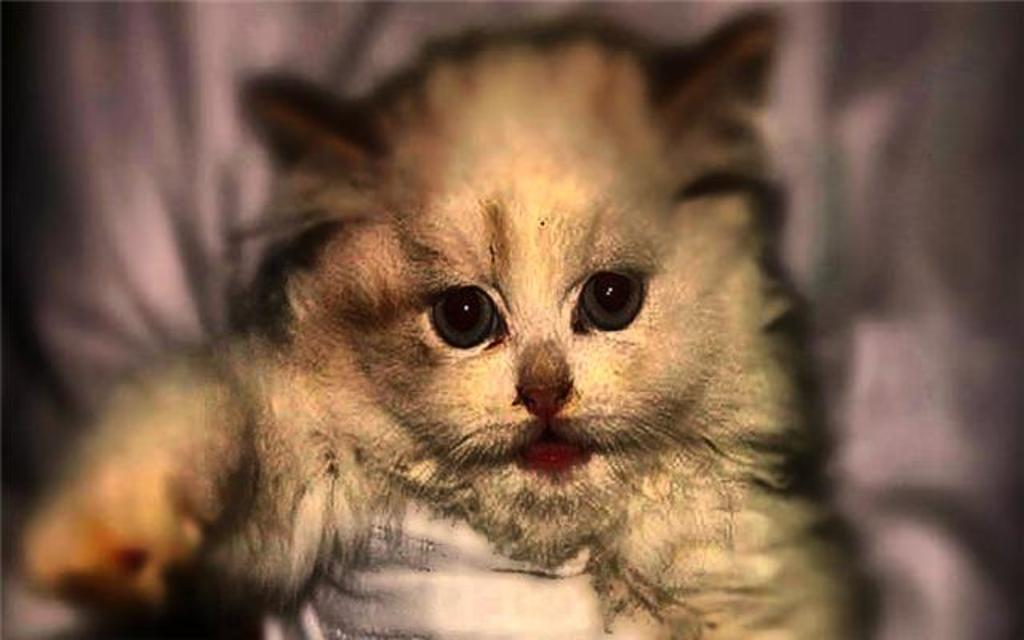What can be observed about the image? The image is edited. What is the main subject in the middle of the image? There is an animal in the middle of the image. Can you see any blood on the animal's toes in the image? There is no blood or toes visible on the animal in the image, as it is an edited image and the animal's features are not clearly discernible. 